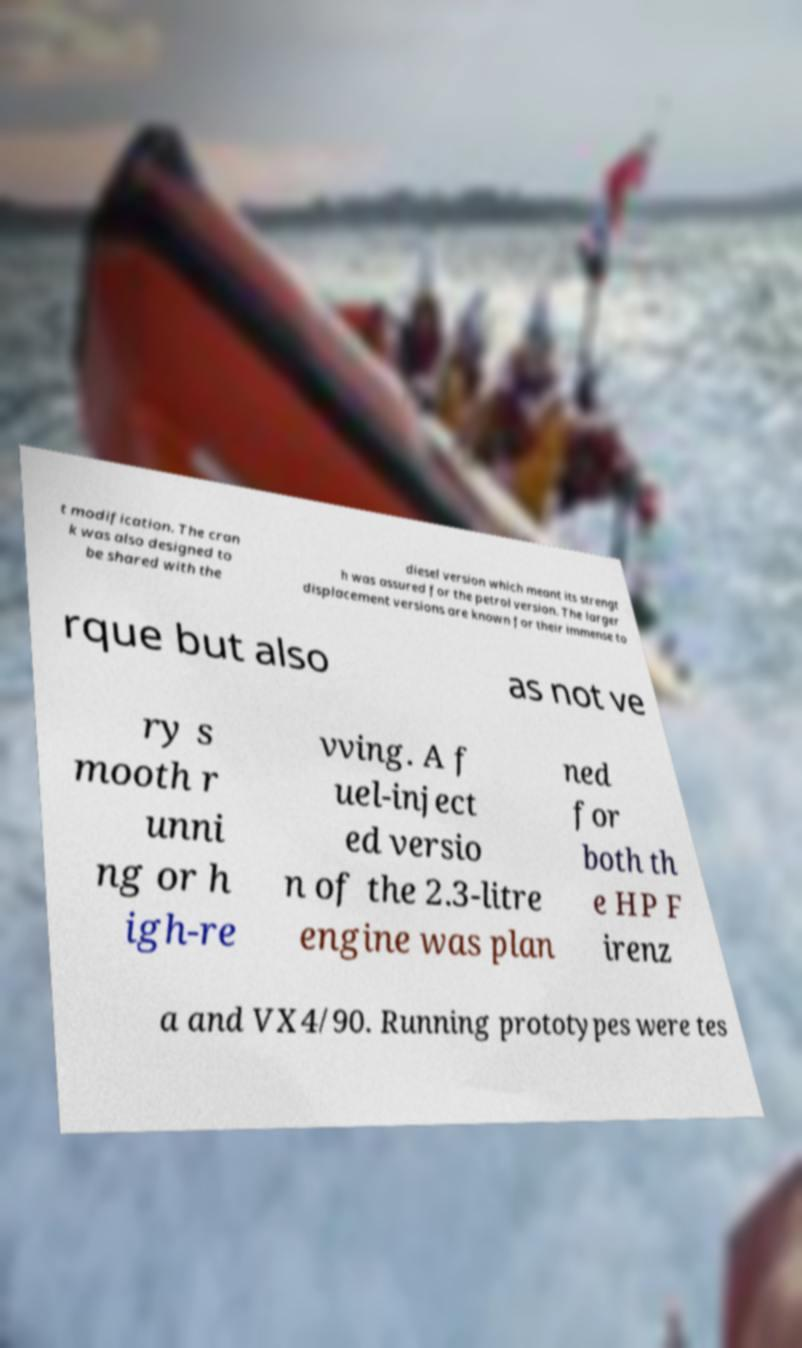Can you read and provide the text displayed in the image?This photo seems to have some interesting text. Can you extract and type it out for me? t modification. The cran k was also designed to be shared with the diesel version which meant its strengt h was assured for the petrol version. The larger displacement versions are known for their immense to rque but also as not ve ry s mooth r unni ng or h igh-re vving. A f uel-inject ed versio n of the 2.3-litre engine was plan ned for both th e HP F irenz a and VX4/90. Running prototypes were tes 